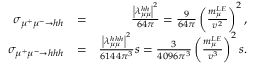<formula> <loc_0><loc_0><loc_500><loc_500>\begin{array} { r l r } { \sigma _ { \mu ^ { + } \mu ^ { - } \to h h } } & { = } & { \frac { \left | \lambda _ { \mu \mu } ^ { h h } \right | ^ { 2 } } { 6 4 \pi } = \frac { 9 } { 6 4 \pi } \left ( \frac { m _ { \mu } ^ { L E } } { v ^ { 2 } } \right ) ^ { 2 } , } \\ { \sigma _ { \mu ^ { + } \mu ^ { - } \to h h h } } & { = } & { \frac { \left | \lambda _ { \mu \mu } ^ { h h h } \right | ^ { 2 } } { 6 1 4 4 \pi ^ { 3 } } s = \frac { 3 } { 4 0 9 6 \pi ^ { 3 } } \left ( \frac { m _ { \mu } ^ { L E } } { v ^ { 3 } } \right ) ^ { 2 } s . } \end{array}</formula> 